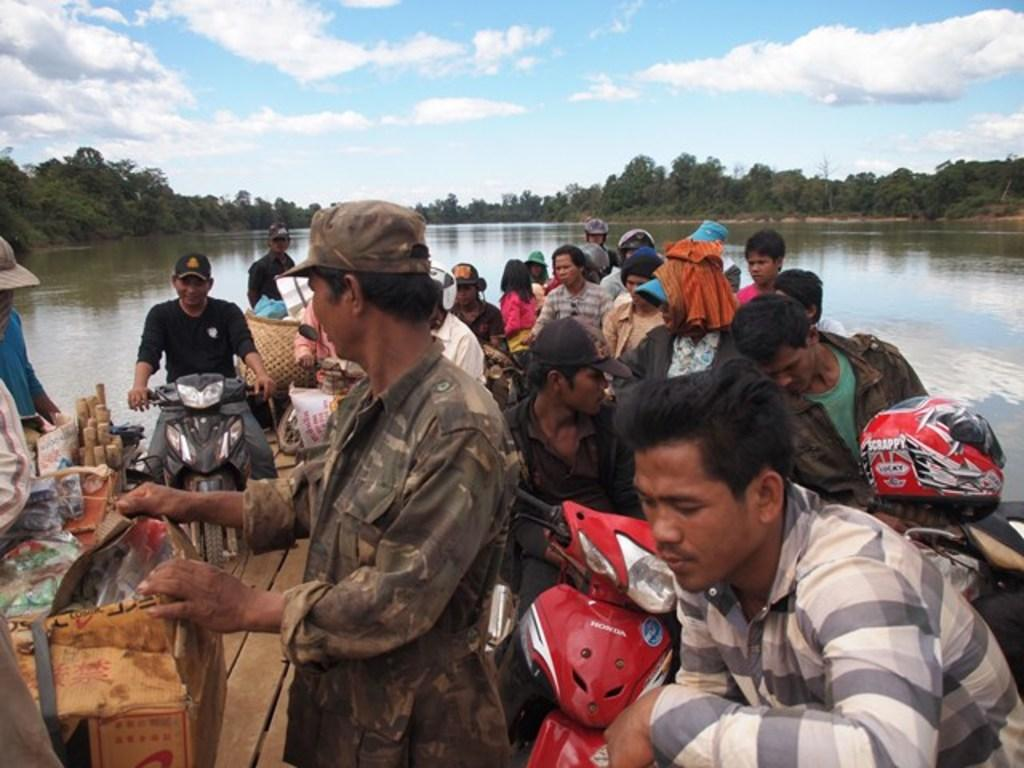Who or what can be seen in the image? There are people in the image. What else is present in the image besides people? There are vehicles in the image. Can you describe the wooden surface in the image? There are objects placed on a wooden surface in the image. What can be seen in the background of the image? There is water and trees visible in the background of the image. How many grapes are being held by the yak in the image? There is no yak or grapes present in the image. 